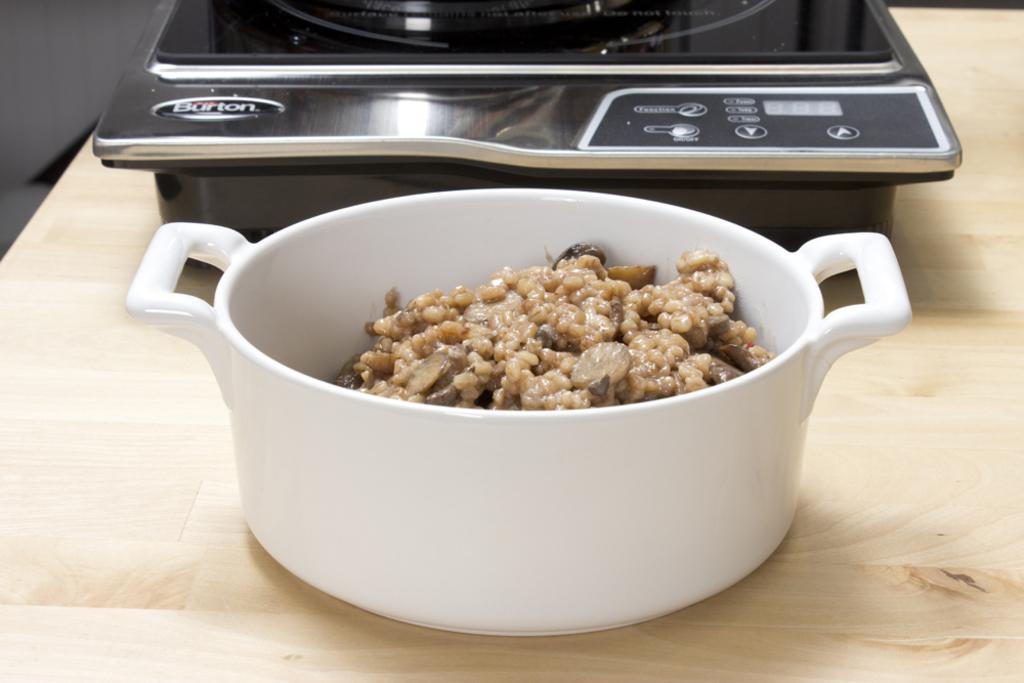<image>
Offer a succinct explanation of the picture presented. A bowl of food on the counter in front of a Burton burner. 